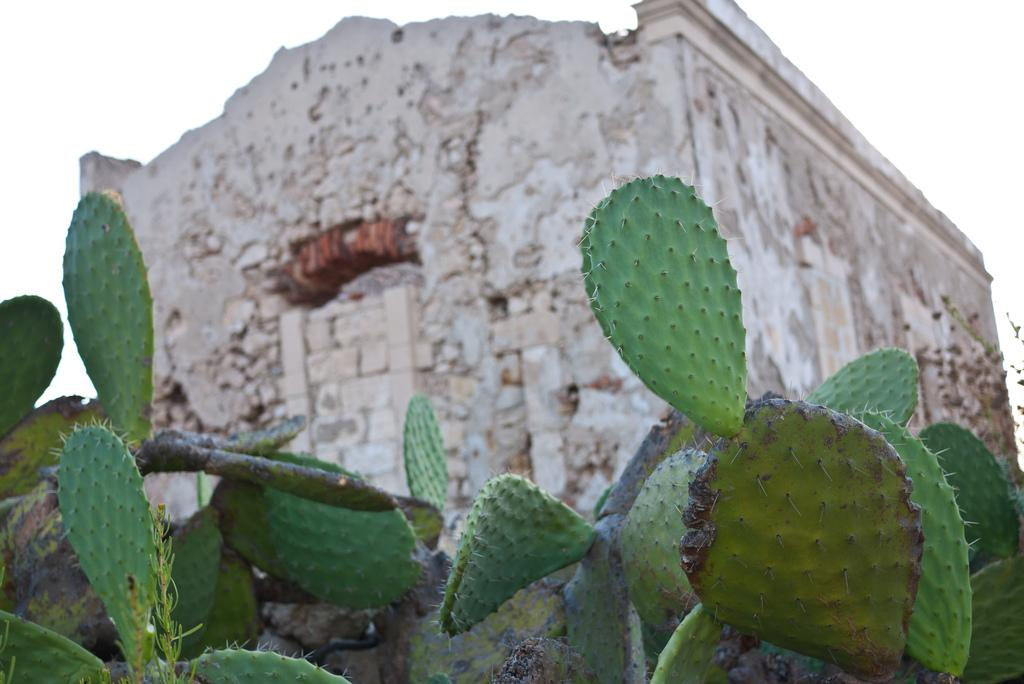What type of structure is depicted in the image? There is a building in the image that resembles a fort. What natural element is present in the image? There is a tree in the image. What type of vegetation is on the ground in the image? There are plants on the ground in the image. What is visible at the top of the image? The sky is visible at the top of the image. How many stamps are on the tree in the image? There are no stamps present in the image; it features a tree and other elements related to the fort-like building and surrounding vegetation. 